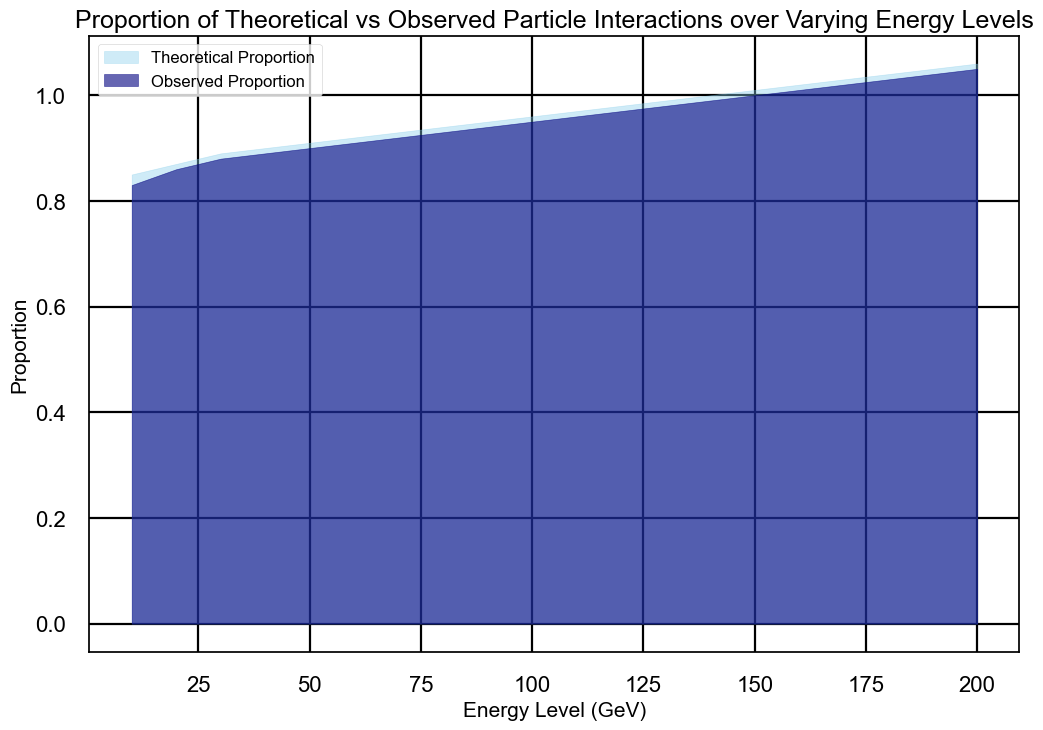What is the highest theoretical proportion shown in the chart? The chart shows that the highest theoretical proportion occurs at the energy level of 200 GeV, where the proportion is 1.06
Answer: 1.06 What is the difference in observed proportion between energy levels of 100 GeV and 50 GeV? At 100 GeV, the observed proportion is 0.95, and at 50 GeV, it is 0.90. The difference is 0.95 - 0.90 = 0.05
Answer: 0.05 At which energy level do the theoretical and observed proportions first reach 1.00? The chart indicates that the theoretical proportion first reaches 1.00 at the energy level of 140 GeV, and the observed proportion reaches it at the level of 150 GeV.
Answer: 140 GeV for theoretical, 150 GeV for observed Compare the increasing trend between theoretical and observed proportions. Are they ever equal? The chart demonstrates that both the theoretical and observed proportions increase almost linearly with the energy level. They never become exactly equal, but they are very close.
Answer: They are very close but not equal What is the average theoretical proportion for energy levels between 10 GeV to 50 GeV? For energy levels 10 to 50 GeV, the theoretical proportions are 0.85, 0.87, 0.89, 0.90, and 0.91. The sum is 4.42. The average is 4.42 / 5 = 0.884.
Answer: 0.884 At which energy level does the difference between theoretical and observed proportions first reach 0.01? The chart shows that at the energy level of 10 GeV, the theoretical proportion is 0.85, and the observed proportion is 0.83, so the difference is already 0.02. The difference becomes 0.01 at 20 GeV, where the theoretical proportion is 0.87 and the observed is 0.86.
Answer: 20 GeV What does the color skyblue represent in the area chart? The skyblue color in the area chart represents the theoretical proportion of particle interactions
Answer: Theoretical proportion Is there any energy level where the theoretical proportion remains constant? No, the chart shows that the theoretical proportion continuously increases with rising energy levels; it does not remain constant at any point.
Answer: No Describe the visual difference in proportions at 200 GeV. At 200 GeV, the theoretical proportion area (in skyblue) is slightly higher than the observed proportion area (in navy). The difference is minor but noticeable, with theoretical at 1.06 and observed at 1.05.
Answer: Theoretical is higher 